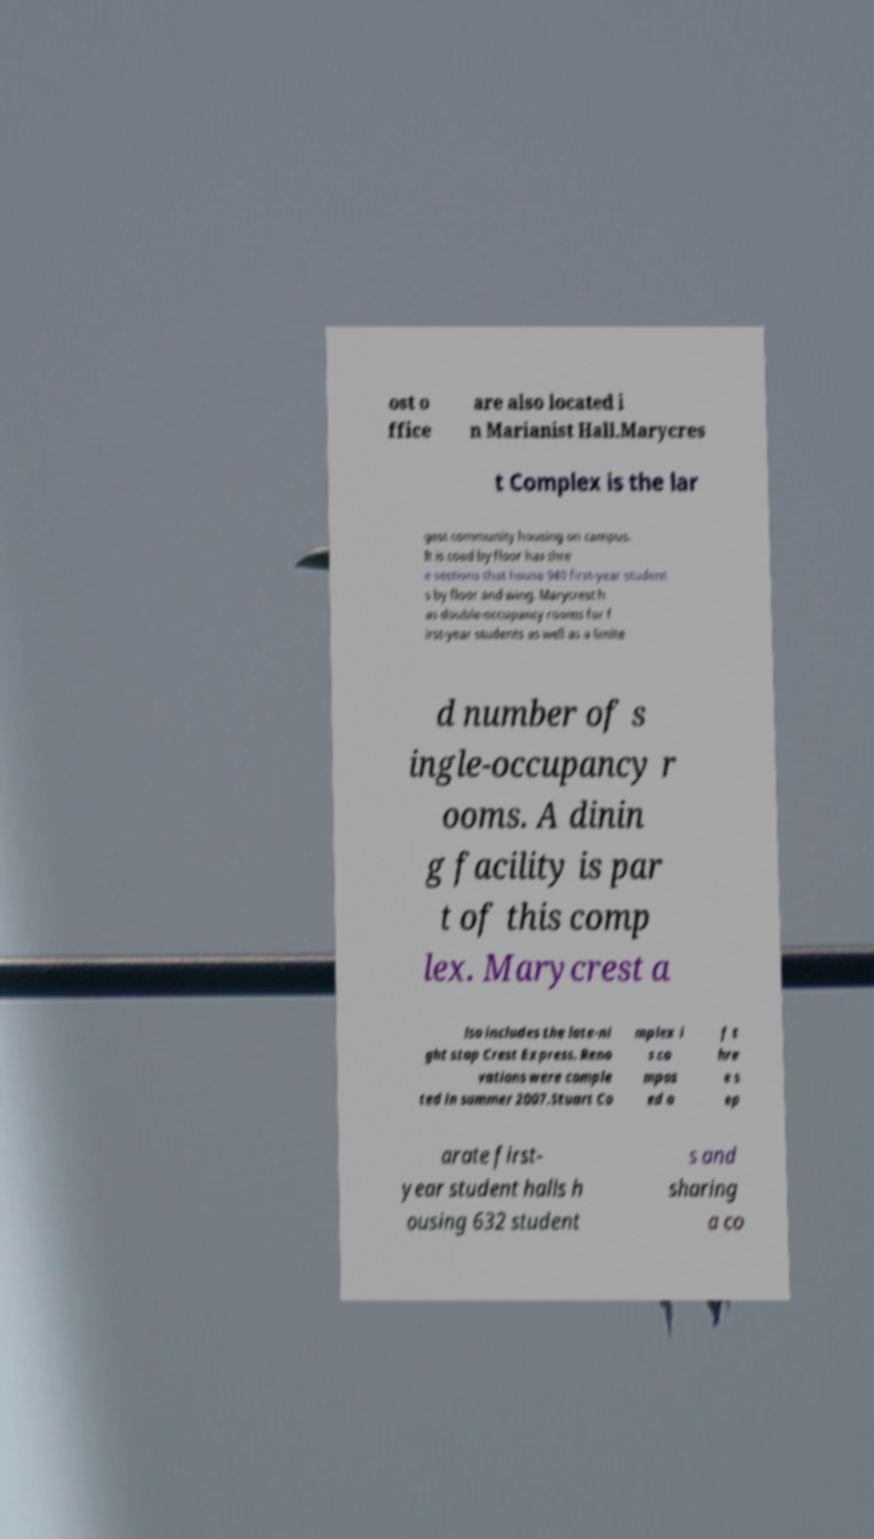Please read and relay the text visible in this image. What does it say? ost o ffice are also located i n Marianist Hall.Marycres t Complex is the lar gest community housing on campus. It is coed by floor has thre e sections that house 940 first-year student s by floor and wing. Marycrest h as double-occupancy rooms for f irst-year students as well as a limite d number of s ingle-occupancy r ooms. A dinin g facility is par t of this comp lex. Marycrest a lso includes the late-ni ght stop Crest Express. Reno vations were comple ted in summer 2007.Stuart Co mplex i s co mpos ed o f t hre e s ep arate first- year student halls h ousing 632 student s and sharing a co 